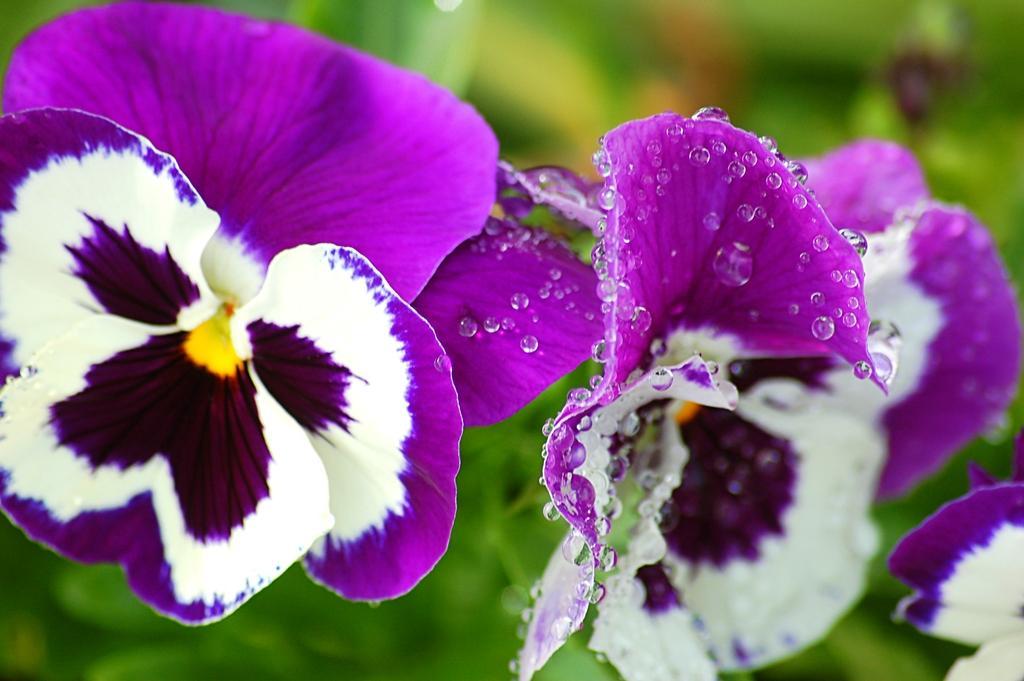How would you summarize this image in a sentence or two? In this picture we can see flowers in the front, there are some water droplets on these flowers, we can see a blurry background. 